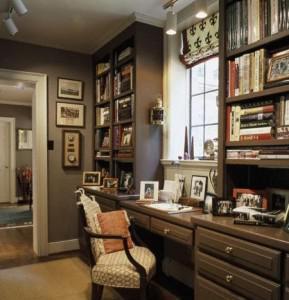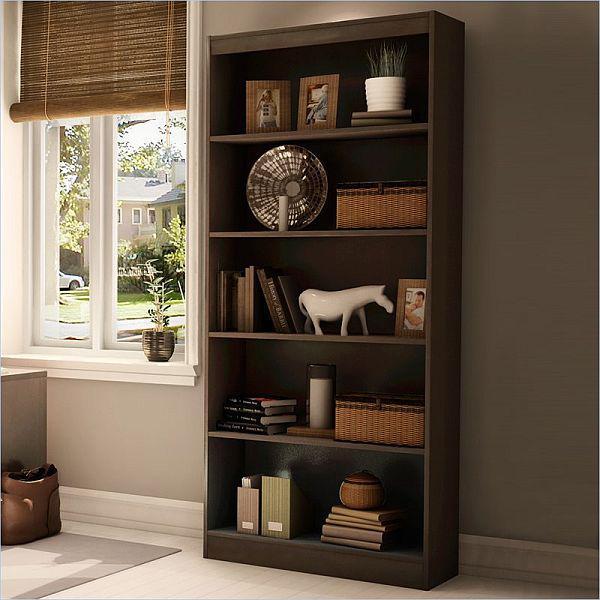The first image is the image on the left, the second image is the image on the right. Considering the images on both sides, is "A window is visible in at least one of the images." valid? Answer yes or no. Yes. The first image is the image on the left, the second image is the image on the right. For the images shown, is this caption "An image shows a tree-inspired wooden bookshelf with platform shelves." true? Answer yes or no. No. 